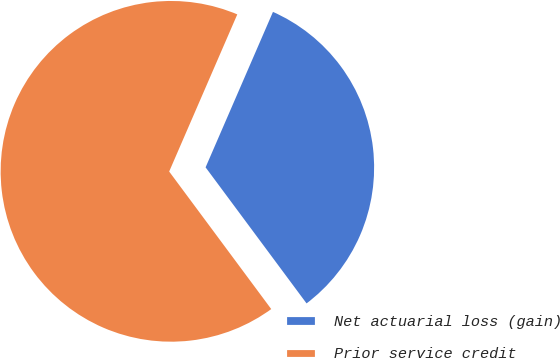<chart> <loc_0><loc_0><loc_500><loc_500><pie_chart><fcel>Net actuarial loss (gain)<fcel>Prior service credit<nl><fcel>33.33%<fcel>66.67%<nl></chart> 